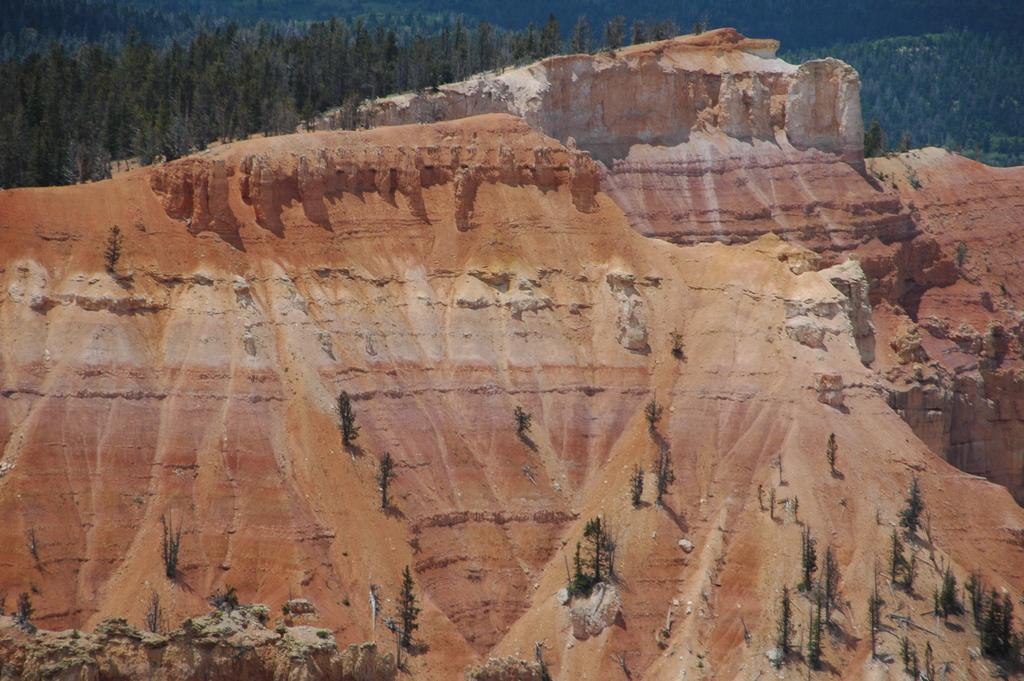What type of natural landform is present in the image? The image contains mountains. What other types of vegetation can be seen in the image? There are plants in the image. What is visible at the top of the image? The sky is visible at the top of the image. Where are the trees located in the image? The trees are on the left side of the image. Can you hear the children laughing in the image? There are no children or laughter present in the image. How many fingers can be seen pointing at the mountain in the image? There are no fingers or people pointing at the mountain in the image. 